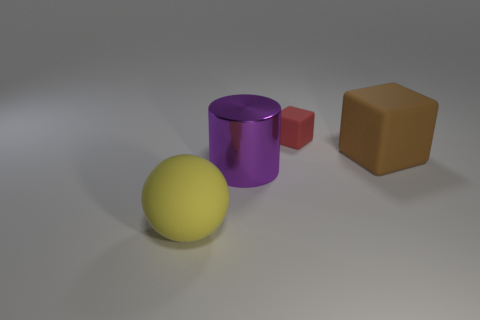What number of other brown matte objects are the same shape as the tiny thing?
Keep it short and to the point. 1. What is the color of the matte cube that is behind the large object that is on the right side of the shiny cylinder?
Your answer should be very brief. Red. Are there an equal number of big purple objects that are to the left of the big cylinder and matte spheres?
Your response must be concise. No. Is there a thing that has the same size as the yellow sphere?
Provide a short and direct response. Yes. Does the brown matte object have the same size as the matte thing behind the brown rubber cube?
Keep it short and to the point. No. Are there an equal number of big purple cylinders that are on the left side of the big purple cylinder and matte blocks that are behind the brown matte object?
Keep it short and to the point. No. There is a object that is behind the large brown thing; what material is it?
Offer a very short reply. Rubber. Does the ball have the same size as the red matte thing?
Provide a succinct answer. No. Is the number of purple metallic things behind the large matte cube greater than the number of gray metal cubes?
Provide a succinct answer. No. There is a yellow object that is made of the same material as the red block; what is its size?
Provide a short and direct response. Large. 